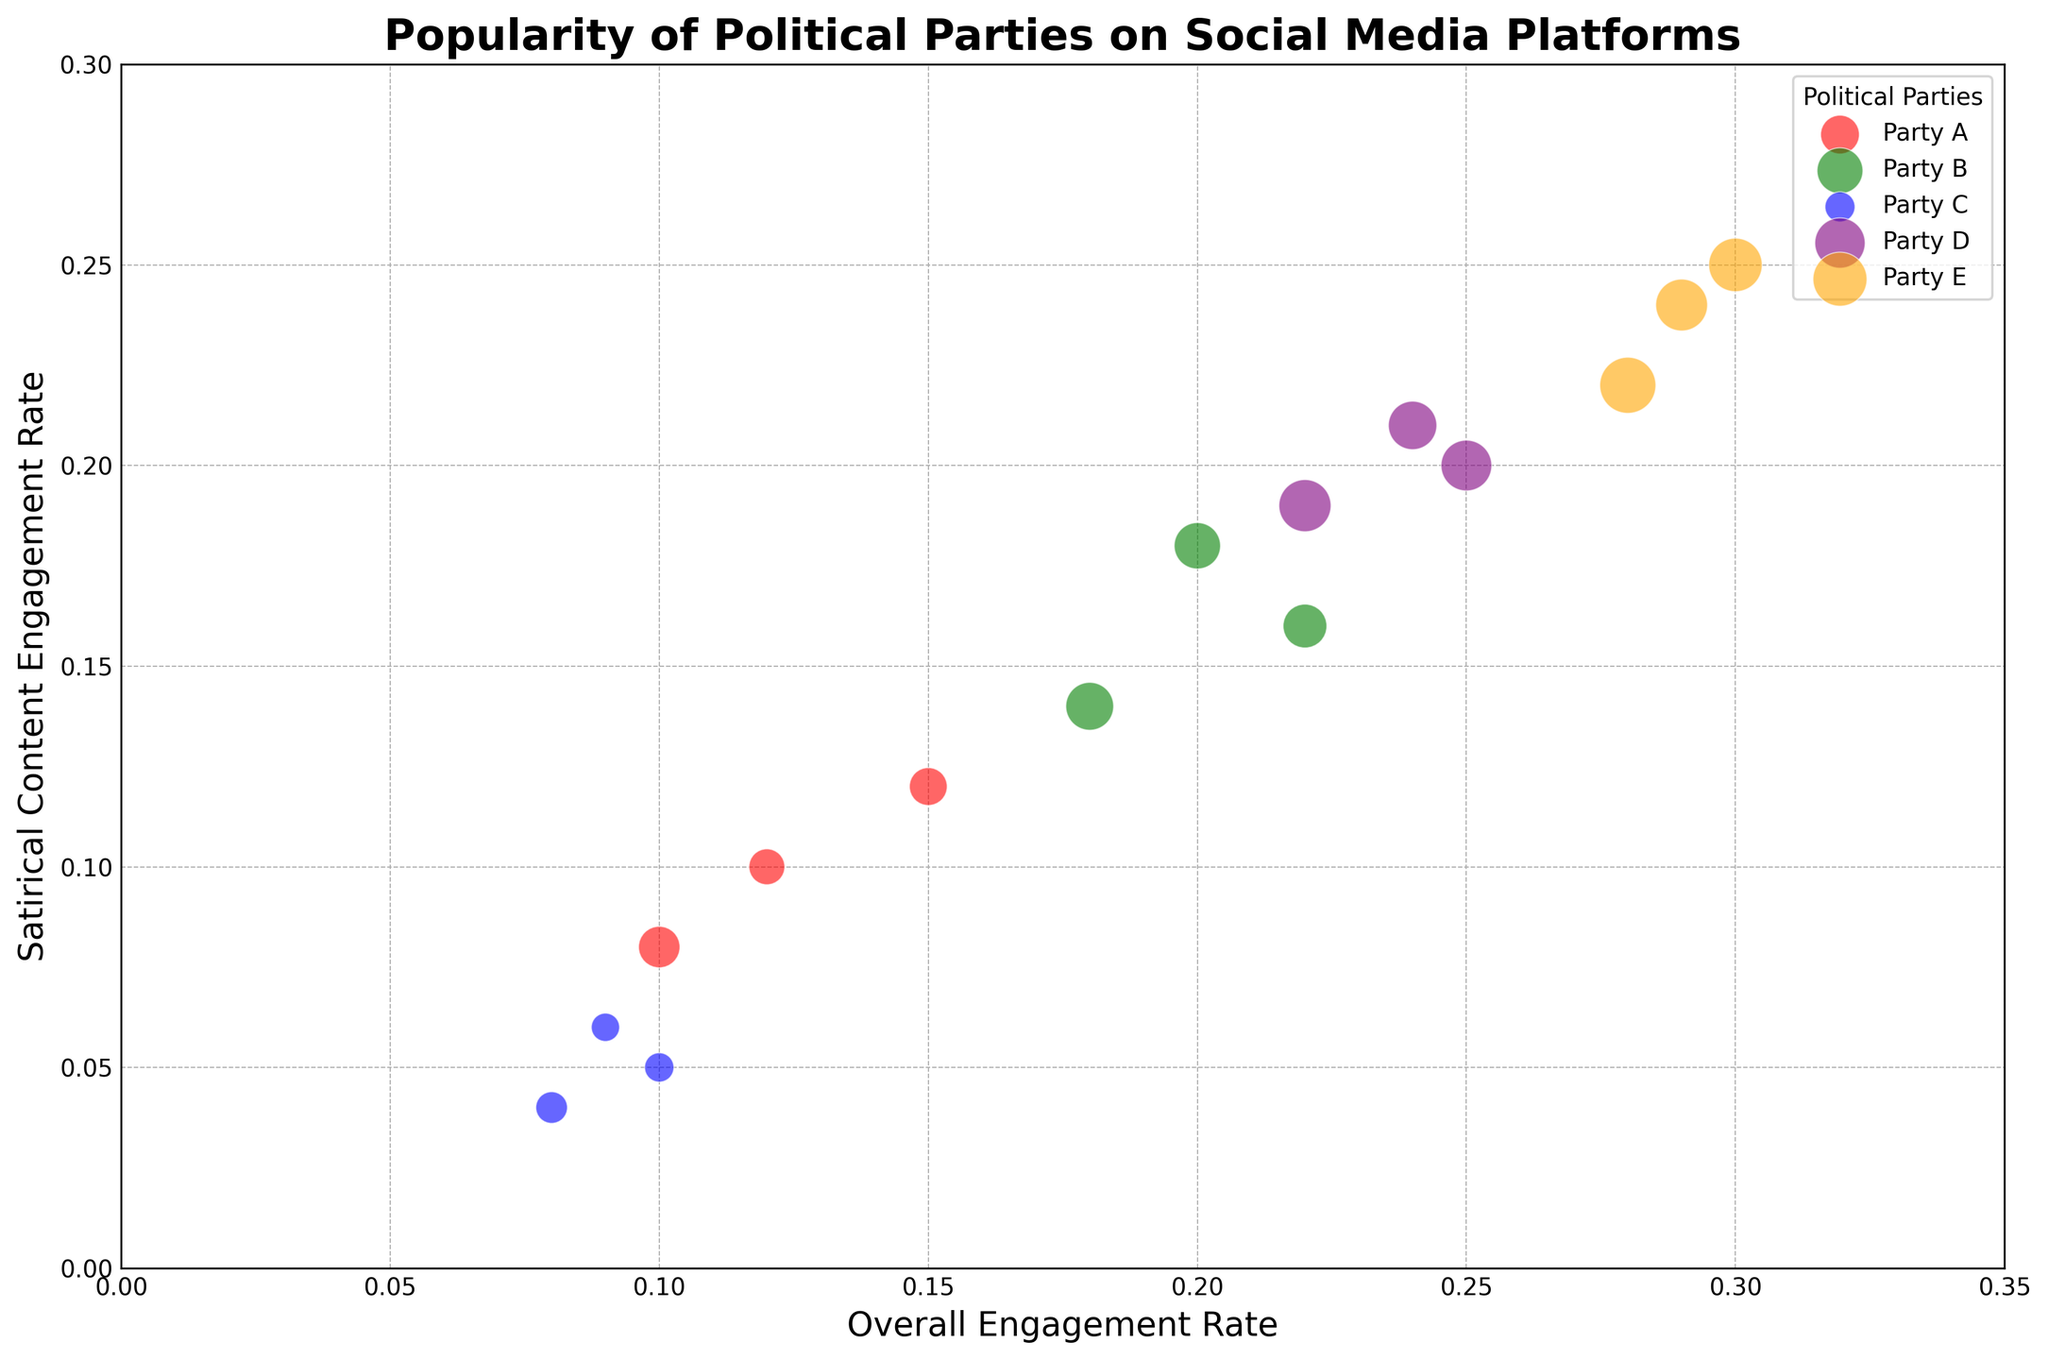What is the party with the highest overall engagement rate on Twitter? To find which party has the highest overall engagement rate on Twitter, compare the engagement rates of the parties on that platform. From the visualization, Party E has the highest bubble on the x-axis for Twitter with an engagement rate of 0.30.
Answer: Party E Which platform sees the lowest engagement rate for Party C? Examine the positions of the bubbles representing Party C (blue bubbles) on each platform on the x-axis. The bubble with the lowest x-axis value corresponds to Facebook at 0.08.
Answer: Facebook How does the engagement rate for satirical content on Instagram for Party D compare to its overall engagement rate on the same platform? Locate the purple bubble for Party D on Instagram. The x-axis gives the overall engagement rate (0.24), and the y-axis gives the satirical content engagement rate (0.21). Compare these values to find that 0.21 is slightly lower than 0.24.
Answer: Satirical content engagement rate is lower What is the overall engagement range for Party B across all platforms? The overall engagement rate for Party B across platforms (Twitter, Facebook, Instagram) ranges from the smallest to largest values on the x-axis. Party B's engagement rates are 0.20, 0.18, and 0.22. The range can be calculated as 0.22 - 0.18 = 0.04.
Answer: 0.04 Which party has the most variability in satirical content engagement rate across platforms? Determine the range of the satirical content engagement rate (y-axis values) for each party across the platforms. Party E has the highest range (0.25 to 0.24) for this variable; although ranges are close, the widest span is detected in Party E.
Answer: Party E Between Party A on Twitter and Party C on Instagram, which has a higher engagement rate for satirical content? Compare the y-axis values for Party A on Twitter (0.12) and Party C on Instagram (0.06). Party A's satirical content engagement rate is higher on Twitter.
Answer: Party A on Twitter Which party consistently shows the highest engagement rates (both overall and satirical) across all platforms? Observe which party has bubbles consistently positioned higher on both the x and y axes across all platforms. Party E consistently has the highest values, indicating the highest engagement rates overall and for satirical content.
Answer: Party E What is the difference in the amount of followers between Party D and Party E on Facebook? Look at the size of the bubbles to infer the number of followers: Party D on Facebook has 950,000 followers and Party E has 1,100,000 followers. The difference is 1,100,000 - 950,000 = 150,000.
Answer: 150,000 